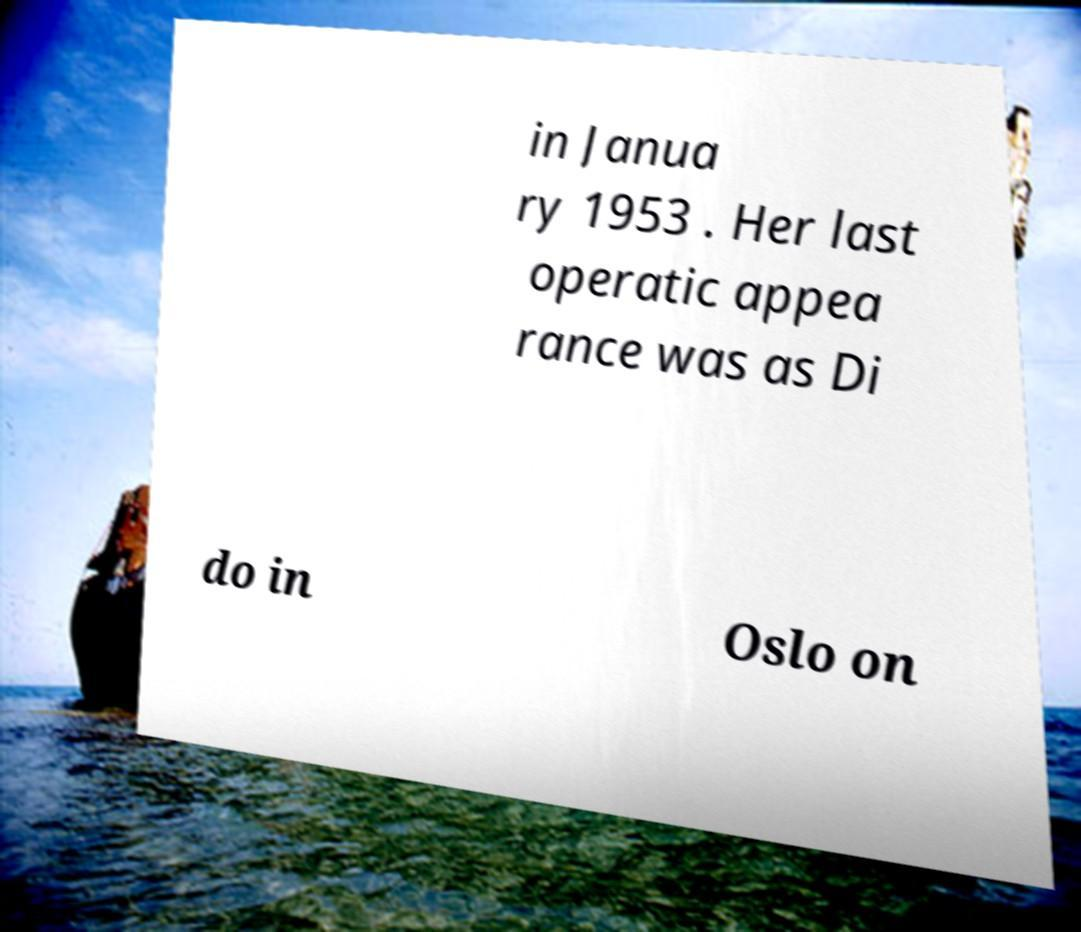Please read and relay the text visible in this image. What does it say? in Janua ry 1953 . Her last operatic appea rance was as Di do in Oslo on 